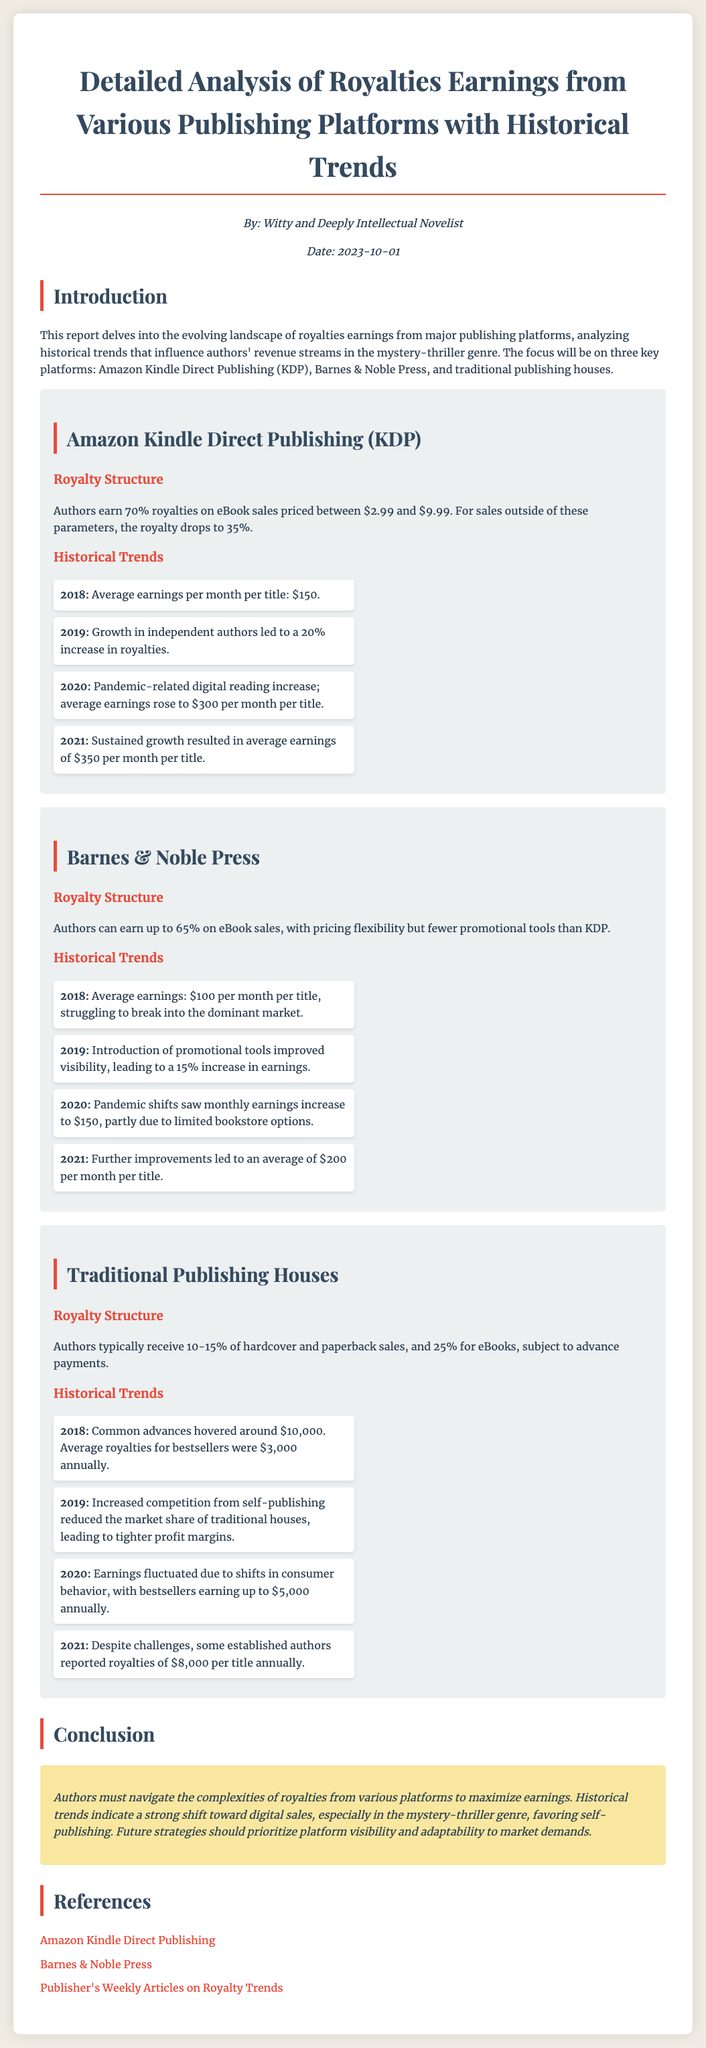What is the royalty percentage for eBooks on Amazon KDP? The document states that authors earn 70% royalties on eBook sales priced between $2.99 and $9.99.
Answer: 70% What was the average earning per month per title on KDP in 2020? The historical trend for 2020 indicates that average earnings rose to $300 per month per title.
Answer: $300 Which publishing platform saw the highest average earnings per month per title in 2021? The document notes that on Amazon KDP, the average earnings in 2021 were $350 per month per title, which is the highest compared to others.
Answer: Amazon KDP What was the average earning from Barnes & Noble Press in 2019? According to the historical trends for Barnes & Noble Press, the average earnings in 2019 were improved to $115 per month per title after a 15% increase.
Answer: $115 Which year saw a significant increase in digital reading due to the pandemic for Amazon KDP? The report highlights that the significant increase in digital reading due to the pandemic was observed in 2020.
Answer: 2020 What was the common advance payment for traditional publishing houses in 2018? The document specifies that common advances in traditional publishing houses hovered around $10,000 in 2018.
Answer: $10,000 What is the maximum royalty percentage that authors can earn from Barnes & Noble Press? The document mentions that authors can earn up to 65% on eBook sales from Barnes & Noble Press.
Answer: 65% What trend did traditional publishing houses face in 2019? The report indicates that in 2019, traditional houses faced increased competition from self-publishing, reducing their market share.
Answer: Increased competition What was the average earning per month per title from traditional publishing in 2021? The document states that some established authors reported royalties of $8,000 per title annually in 2021, translating to approximately $667 per month per title.
Answer: $667 